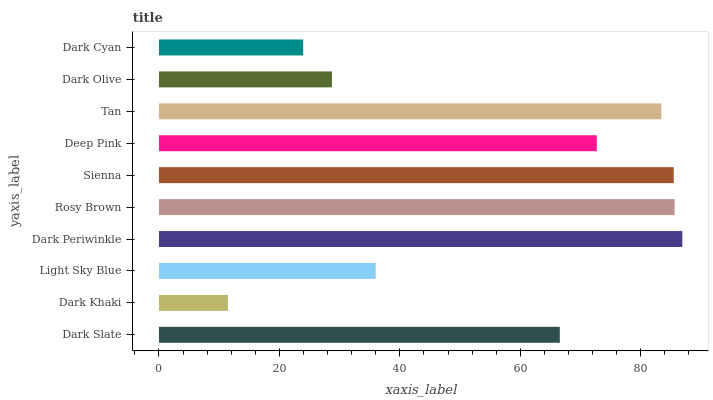Is Dark Khaki the minimum?
Answer yes or no. Yes. Is Dark Periwinkle the maximum?
Answer yes or no. Yes. Is Light Sky Blue the minimum?
Answer yes or no. No. Is Light Sky Blue the maximum?
Answer yes or no. No. Is Light Sky Blue greater than Dark Khaki?
Answer yes or no. Yes. Is Dark Khaki less than Light Sky Blue?
Answer yes or no. Yes. Is Dark Khaki greater than Light Sky Blue?
Answer yes or no. No. Is Light Sky Blue less than Dark Khaki?
Answer yes or no. No. Is Deep Pink the high median?
Answer yes or no. Yes. Is Dark Slate the low median?
Answer yes or no. Yes. Is Dark Khaki the high median?
Answer yes or no. No. Is Dark Cyan the low median?
Answer yes or no. No. 